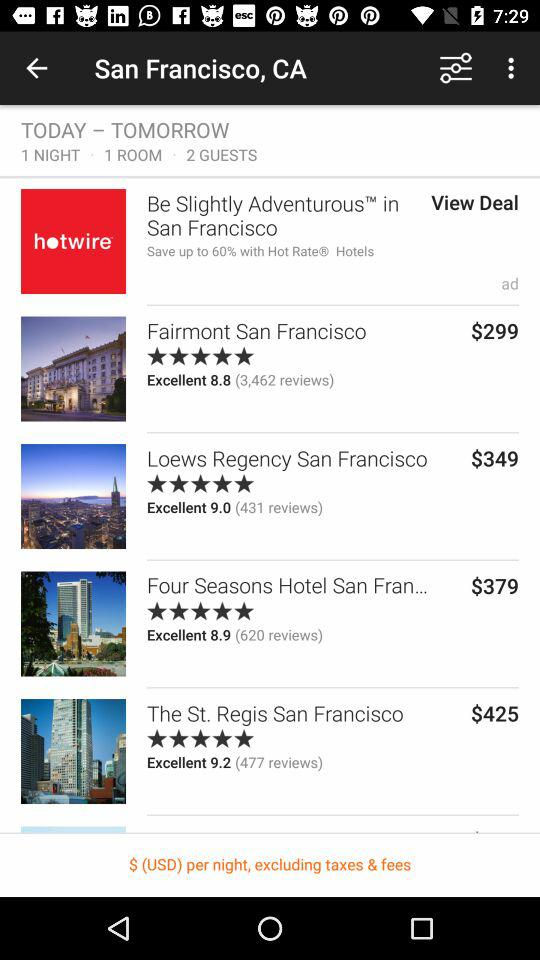How much more does the most expensive hotel cost than the least expensive hotel?
Answer the question using a single word or phrase. 126 